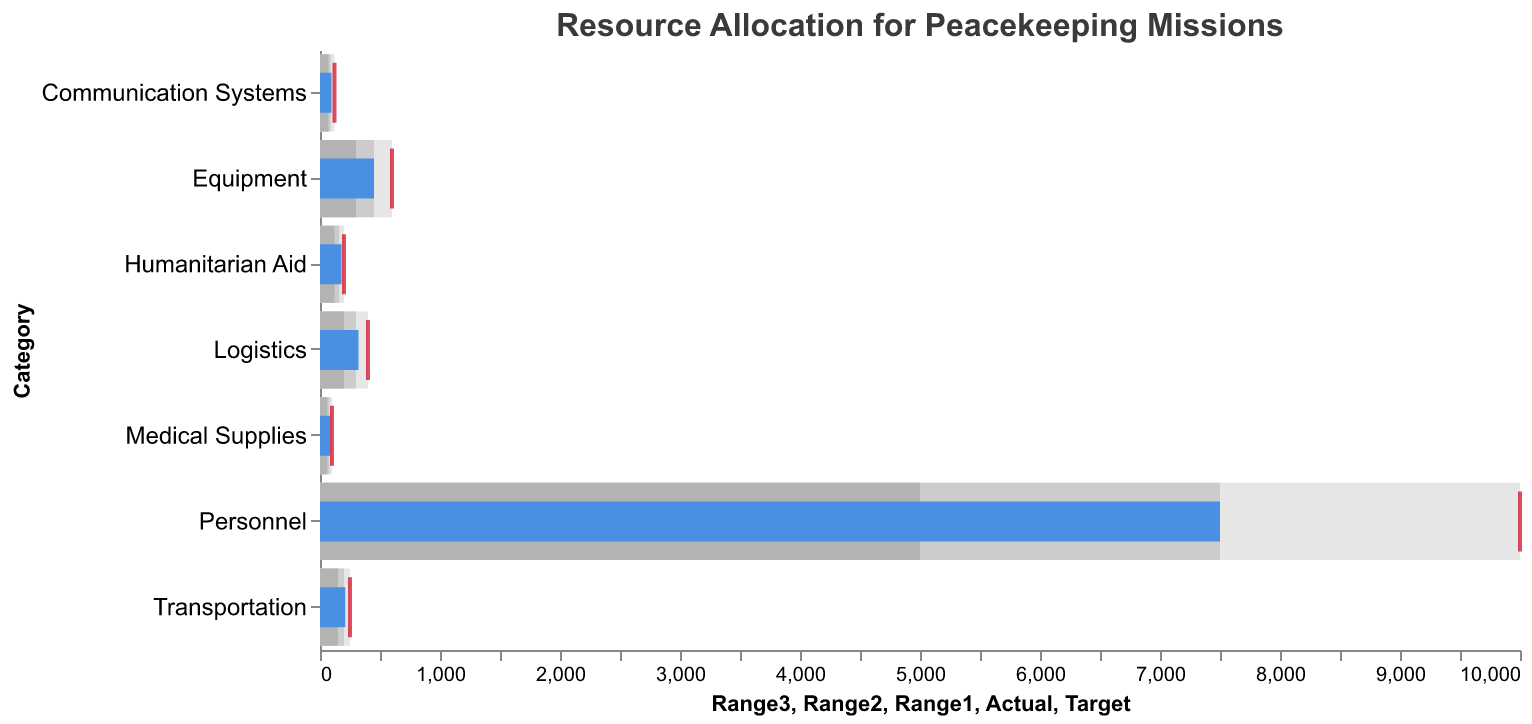What is the title of the figure? The title of the figure is usually displayed prominently at the top. It helps to understand the overall topic of the visual.
Answer: Resource Allocation for Peacekeeping Missions How many categories of resources are shown in the bullet chart? To determine the number of categories, count the unique labels on the y-axis, which represent different resource categories.
Answer: Seven Which category has the highest actual resource allocation? Look for the longest blue bar representing 'Actual' values among all the categories. This visually points out the highest resource allocation.
Answer: Personnel Does the Equipment allocation meet its target? Compare the length of the blue bar (Actual) for Equipment with the target tick mark (red) on the same line.
Answer: No Which category is closest to meeting its target allocation? Inspect all categories to see which blue bar ('Actual') is closest to the red tick mark ('Target'). The smaller the gap, the closer it is.
Answer: Medical Supplies How much more resource is needed for Logistics to meet its target? Subtract the Actual value of Logistics from its Target value (400 - 320). This basic arithmetic shows the additional resources required.
Answer: 80 Which two categories have the largest difference in their actual allocations? Compare the differences in Actual values of all categories. Calculate and find the pair with the greatest discrepancy.
Answer: Personnel and Medical Supplies What is the average actual allocation of all categories combined? Add up all 'Actual' values and divide by the number of categories (7500 + 450 + 320 + 85 + 210 + 95 + 180) / 7. This operation finds the mean value.
Answer: 1191.4 (rounded) Which category has the smallest range of resource allocation? Find the category where the difference between the highest range (Range3) and the lowest range (Range1) is minimal. For each category, calculate Range3 - Range1.
Answer: Medical Supplies Is the allocation for Humanitarian Aid above its mid-range value? Compare the Actual value of Humanitarian Aid to its Range2 value (160). If Actual is greater than Range2, it is above the mid-range.
Answer: Yes 